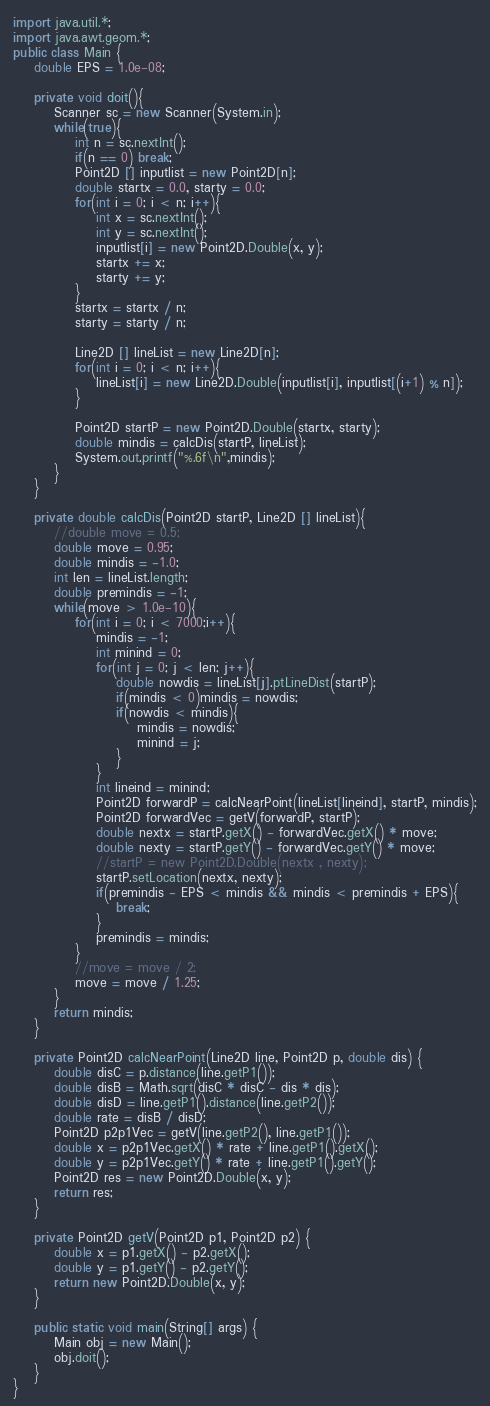<code> <loc_0><loc_0><loc_500><loc_500><_Java_>import java.util.*;
import java.awt.geom.*;
public class Main {
	double EPS = 1.0e-08;

	private void doit(){
		Scanner sc = new Scanner(System.in);
		while(true){
			int n = sc.nextInt();
			if(n == 0) break;
			Point2D [] inputlist = new Point2D[n];
			double startx = 0.0, starty = 0.0;
			for(int i = 0; i < n; i++){
				int x = sc.nextInt();
				int y = sc.nextInt();
				inputlist[i] = new Point2D.Double(x, y);
				startx += x;
				starty += y;
			}
			startx = startx / n;
			starty = starty / n;
			
			Line2D [] lineList = new Line2D[n];
			for(int i = 0; i < n; i++){
				lineList[i] = new Line2D.Double(inputlist[i], inputlist[(i+1) % n]);
			}
			
			Point2D startP = new Point2D.Double(startx, starty);
			double mindis = calcDis(startP, lineList);
			System.out.printf("%.6f\n",mindis);
		}
	}
	
	private double calcDis(Point2D startP, Line2D [] lineList){
		//double move = 0.5;
		double move = 0.95;
		double mindis = -1.0;
		int len = lineList.length;
		double premindis = -1;
		while(move > 1.0e-10){
			for(int i = 0; i < 7000;i++){
				mindis = -1;
				int minind = 0;
				for(int j = 0; j < len; j++){
					double nowdis = lineList[j].ptLineDist(startP);
					if(mindis < 0)mindis = nowdis;
					if(nowdis < mindis){
						mindis = nowdis;
						minind = j;
					}
				}
				int lineind = minind;
				Point2D forwardP = calcNearPoint(lineList[lineind], startP, mindis);
				Point2D forwardVec = getV(forwardP, startP);
				double nextx = startP.getX() - forwardVec.getX() * move;
				double nexty = startP.getY() - forwardVec.getY() * move;
				//startP = new Point2D.Double(nextx , nexty);
				startP.setLocation(nextx, nexty);
				if(premindis - EPS < mindis && mindis < premindis + EPS){
					break;
				}
				premindis = mindis;
			}
			//move = move / 2;
			move = move / 1.25;
		}
		return mindis;
	}

	private Point2D calcNearPoint(Line2D line, Point2D p, double dis) {
		double disC = p.distance(line.getP1());
		double disB = Math.sqrt(disC * disC - dis * dis);
		double disD = line.getP1().distance(line.getP2());
		double rate = disB / disD;
		Point2D p2p1Vec = getV(line.getP2(), line.getP1());
		double x = p2p1Vec.getX() * rate + line.getP1().getX();
		double y = p2p1Vec.getY() * rate + line.getP1().getY();
		Point2D res = new Point2D.Double(x, y);
		return res;
	}

	private Point2D getV(Point2D p1, Point2D p2) {
		double x = p1.getX() - p2.getX();
		double y = p1.getY() - p2.getY();
		return new Point2D.Double(x, y);
	}

	public static void main(String[] args) {
		Main obj = new Main();
		obj.doit();
	}
}</code> 